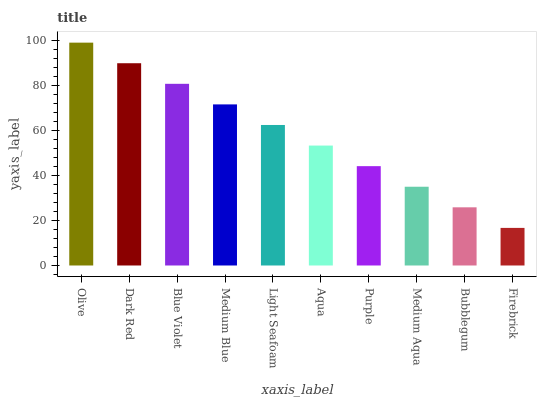Is Firebrick the minimum?
Answer yes or no. Yes. Is Olive the maximum?
Answer yes or no. Yes. Is Dark Red the minimum?
Answer yes or no. No. Is Dark Red the maximum?
Answer yes or no. No. Is Olive greater than Dark Red?
Answer yes or no. Yes. Is Dark Red less than Olive?
Answer yes or no. Yes. Is Dark Red greater than Olive?
Answer yes or no. No. Is Olive less than Dark Red?
Answer yes or no. No. Is Light Seafoam the high median?
Answer yes or no. Yes. Is Aqua the low median?
Answer yes or no. Yes. Is Bubblegum the high median?
Answer yes or no. No. Is Blue Violet the low median?
Answer yes or no. No. 